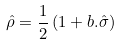<formula> <loc_0><loc_0><loc_500><loc_500>\hat { \rho } = \frac { 1 } { 2 } \left ( 1 + b . \hat { \sigma } \right )</formula> 